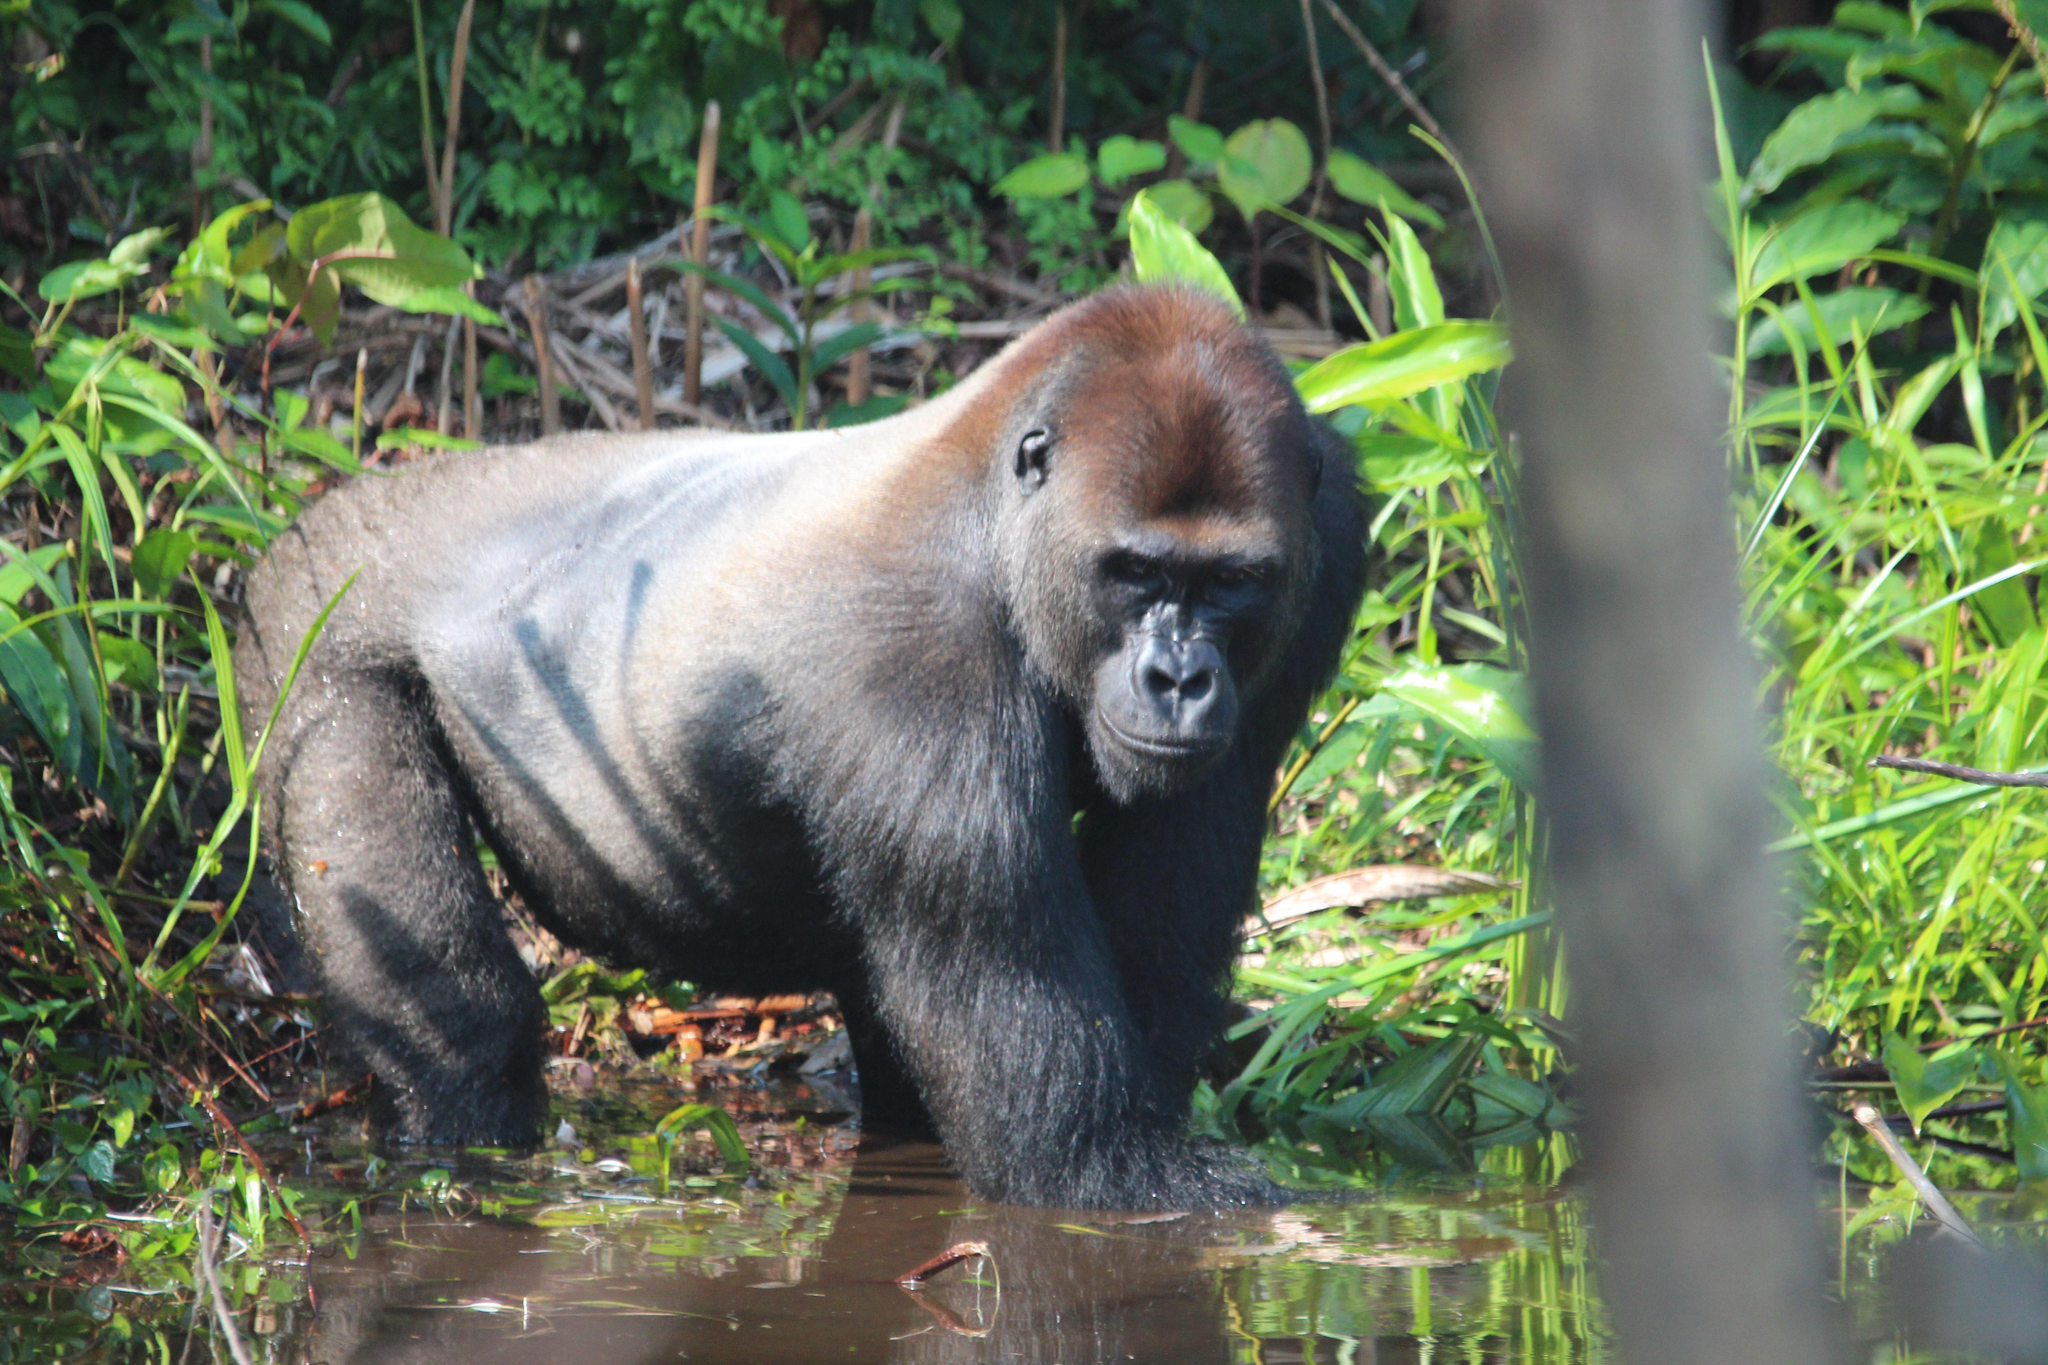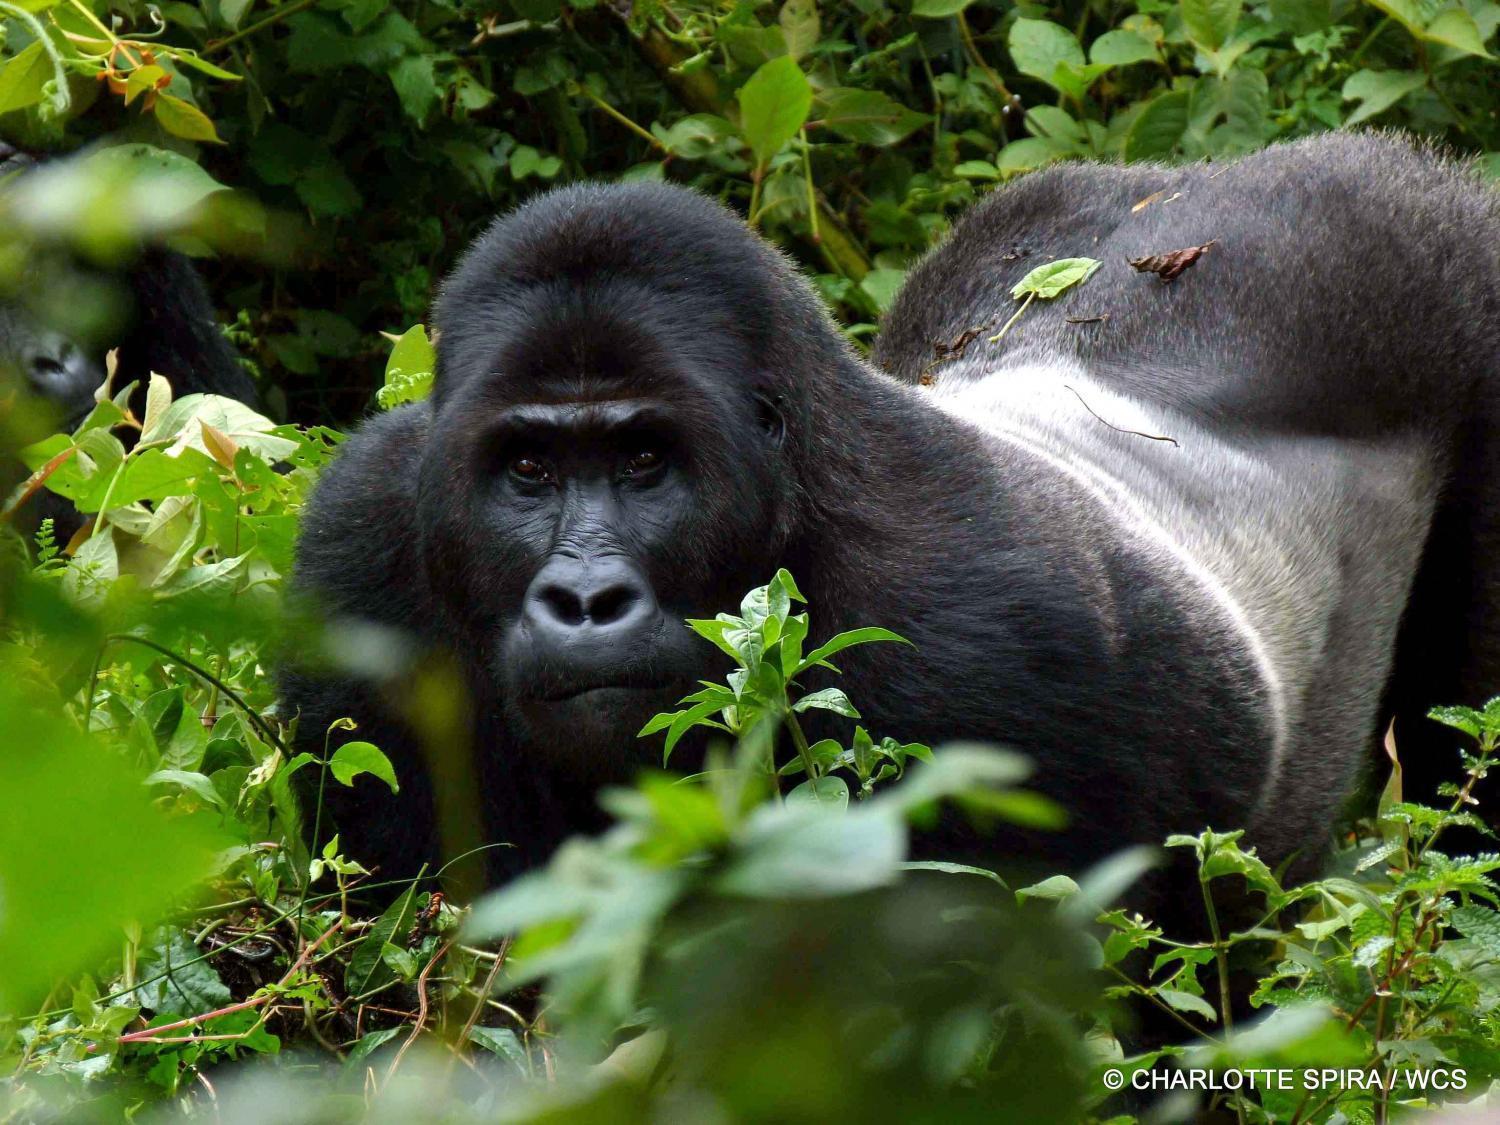The first image is the image on the left, the second image is the image on the right. Evaluate the accuracy of this statement regarding the images: "Each gorilla is standing on at least two legs.". Is it true? Answer yes or no. Yes. The first image is the image on the left, the second image is the image on the right. Considering the images on both sides, is "An image shows one man in a scene with a dark-haired ape." valid? Answer yes or no. No. 